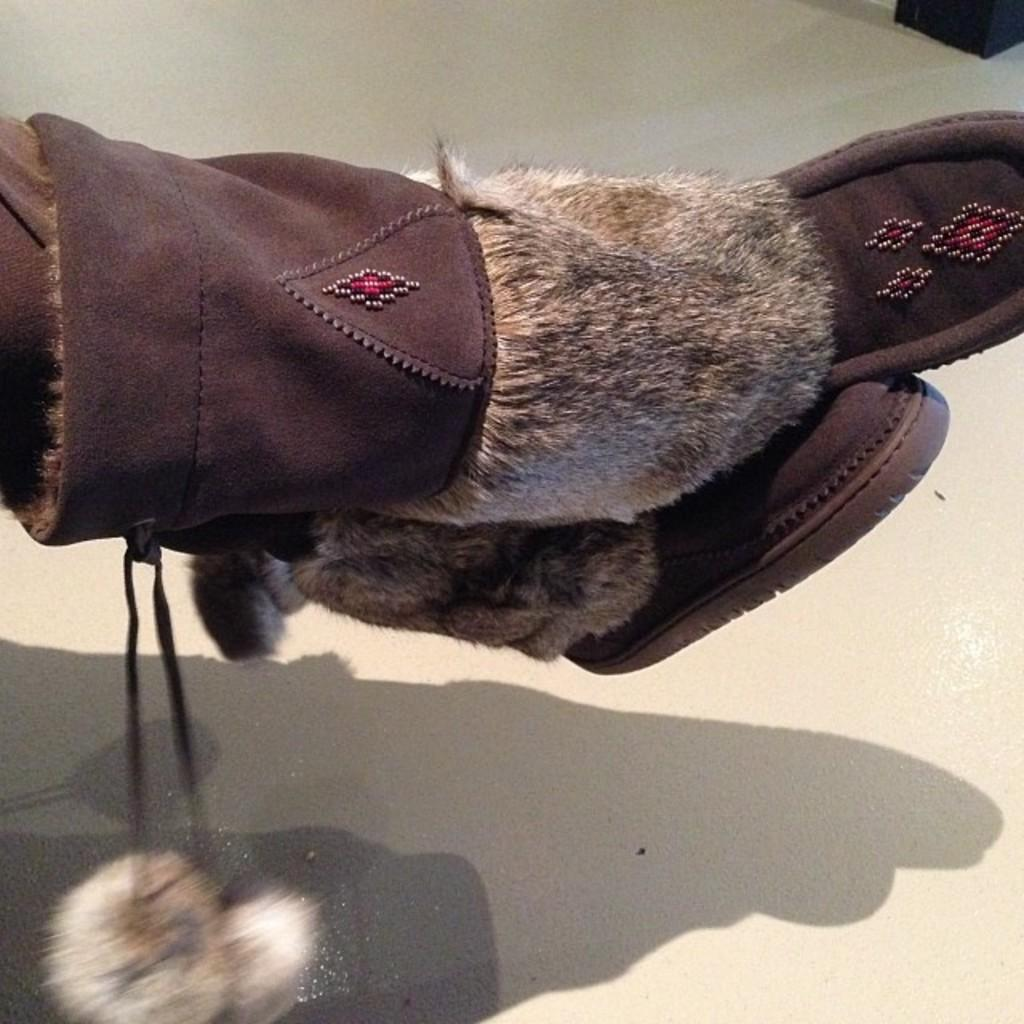What body part is visible in the image? There are legs visible in the image. What type of footwear is the person wearing? The person is wearing boots. What type of cough medicine is the girl holding in the image? There is no girl or cough medicine present in the image. 